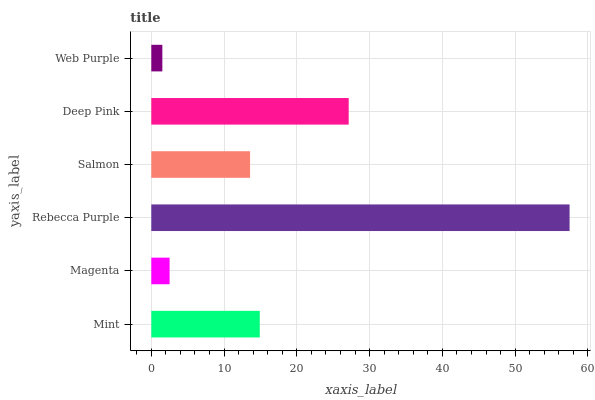Is Web Purple the minimum?
Answer yes or no. Yes. Is Rebecca Purple the maximum?
Answer yes or no. Yes. Is Magenta the minimum?
Answer yes or no. No. Is Magenta the maximum?
Answer yes or no. No. Is Mint greater than Magenta?
Answer yes or no. Yes. Is Magenta less than Mint?
Answer yes or no. Yes. Is Magenta greater than Mint?
Answer yes or no. No. Is Mint less than Magenta?
Answer yes or no. No. Is Mint the high median?
Answer yes or no. Yes. Is Salmon the low median?
Answer yes or no. Yes. Is Salmon the high median?
Answer yes or no. No. Is Deep Pink the low median?
Answer yes or no. No. 